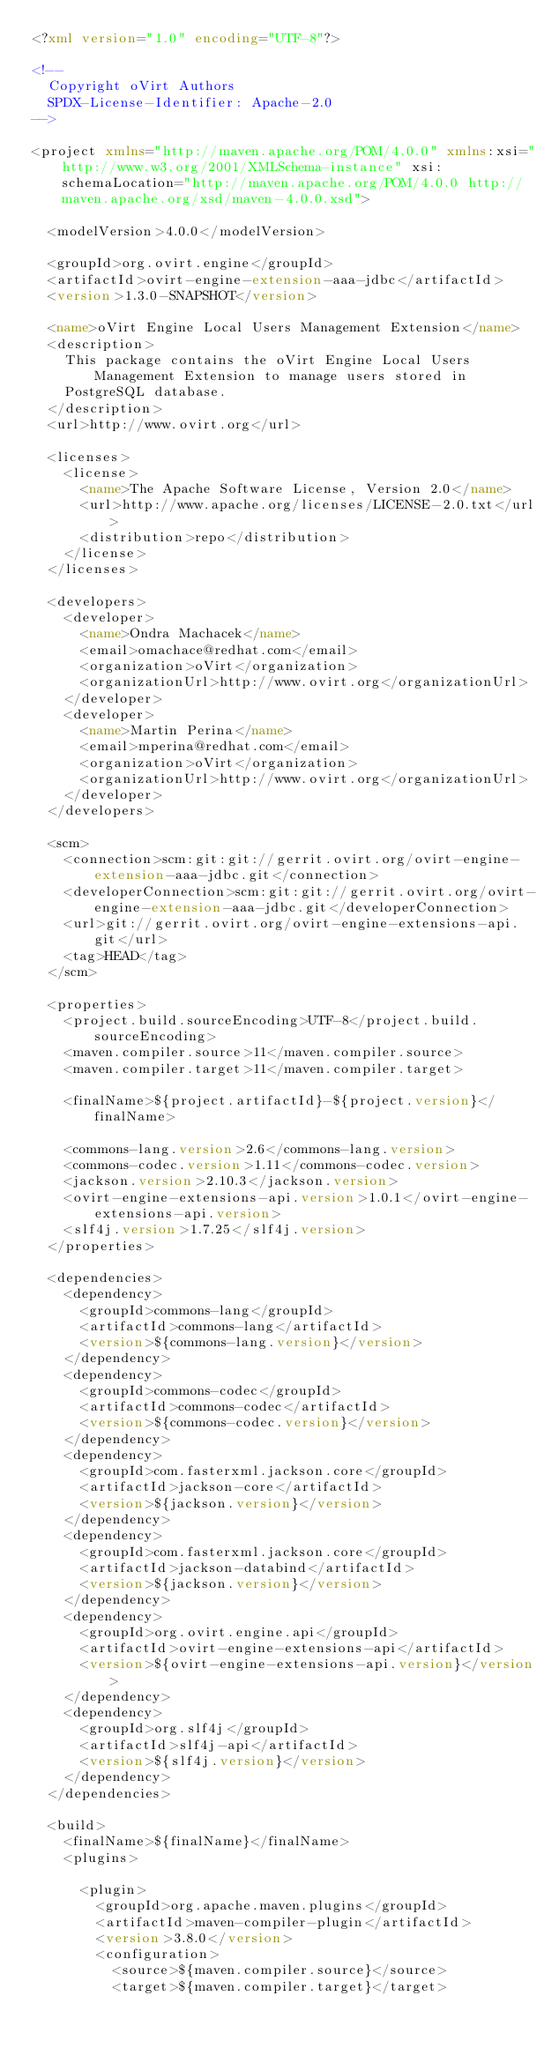<code> <loc_0><loc_0><loc_500><loc_500><_XML_><?xml version="1.0" encoding="UTF-8"?>

<!--
  Copyright oVirt Authors
  SPDX-License-Identifier: Apache-2.0
-->

<project xmlns="http://maven.apache.org/POM/4.0.0" xmlns:xsi="http://www.w3.org/2001/XMLSchema-instance" xsi:schemaLocation="http://maven.apache.org/POM/4.0.0 http://maven.apache.org/xsd/maven-4.0.0.xsd">

  <modelVersion>4.0.0</modelVersion>

  <groupId>org.ovirt.engine</groupId>
  <artifactId>ovirt-engine-extension-aaa-jdbc</artifactId>
  <version>1.3.0-SNAPSHOT</version>

  <name>oVirt Engine Local Users Management Extension</name>
  <description>
    This package contains the oVirt Engine Local Users Management Extension to manage users stored in
    PostgreSQL database.
  </description>
  <url>http://www.ovirt.org</url>

  <licenses>
    <license>
      <name>The Apache Software License, Version 2.0</name>
      <url>http://www.apache.org/licenses/LICENSE-2.0.txt</url>
      <distribution>repo</distribution>
    </license>
  </licenses>

  <developers>
    <developer>
      <name>Ondra Machacek</name>
      <email>omachace@redhat.com</email>
      <organization>oVirt</organization>
      <organizationUrl>http://www.ovirt.org</organizationUrl>
    </developer>
    <developer>
      <name>Martin Perina</name>
      <email>mperina@redhat.com</email>
      <organization>oVirt</organization>
      <organizationUrl>http://www.ovirt.org</organizationUrl>
    </developer>
  </developers>

  <scm>
    <connection>scm:git:git://gerrit.ovirt.org/ovirt-engine-extension-aaa-jdbc.git</connection>
    <developerConnection>scm:git:git://gerrit.ovirt.org/ovirt-engine-extension-aaa-jdbc.git</developerConnection>
    <url>git://gerrit.ovirt.org/ovirt-engine-extensions-api.git</url>
    <tag>HEAD</tag>
  </scm>

  <properties>
    <project.build.sourceEncoding>UTF-8</project.build.sourceEncoding>
    <maven.compiler.source>11</maven.compiler.source>
    <maven.compiler.target>11</maven.compiler.target>

    <finalName>${project.artifactId}-${project.version}</finalName>

    <commons-lang.version>2.6</commons-lang.version>
    <commons-codec.version>1.11</commons-codec.version>
    <jackson.version>2.10.3</jackson.version>
    <ovirt-engine-extensions-api.version>1.0.1</ovirt-engine-extensions-api.version>
    <slf4j.version>1.7.25</slf4j.version>
  </properties>

  <dependencies>
    <dependency>
      <groupId>commons-lang</groupId>
      <artifactId>commons-lang</artifactId>
      <version>${commons-lang.version}</version>
    </dependency>
    <dependency>
      <groupId>commons-codec</groupId>
      <artifactId>commons-codec</artifactId>
      <version>${commons-codec.version}</version>
    </dependency>
    <dependency>
      <groupId>com.fasterxml.jackson.core</groupId>
      <artifactId>jackson-core</artifactId>
      <version>${jackson.version}</version>
    </dependency>
    <dependency>
      <groupId>com.fasterxml.jackson.core</groupId>
      <artifactId>jackson-databind</artifactId>
      <version>${jackson.version}</version>
    </dependency>
    <dependency>
      <groupId>org.ovirt.engine.api</groupId>
      <artifactId>ovirt-engine-extensions-api</artifactId>
      <version>${ovirt-engine-extensions-api.version}</version>
    </dependency>
    <dependency>
      <groupId>org.slf4j</groupId>
      <artifactId>slf4j-api</artifactId>
      <version>${slf4j.version}</version>
    </dependency>
  </dependencies>

  <build>
    <finalName>${finalName}</finalName>
    <plugins>

      <plugin>
        <groupId>org.apache.maven.plugins</groupId>
        <artifactId>maven-compiler-plugin</artifactId>
        <version>3.8.0</version>
        <configuration>
          <source>${maven.compiler.source}</source>
          <target>${maven.compiler.target}</target></code> 